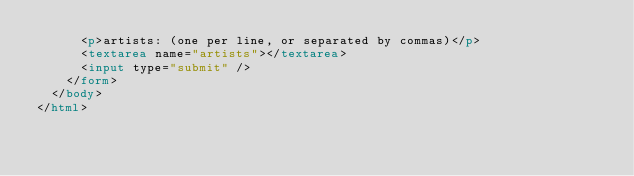<code> <loc_0><loc_0><loc_500><loc_500><_HTML_>      <p>artists: (one per line, or separated by commas)</p>
      <textarea name="artists"></textarea>
      <input type="submit" />
    </form>
  </body>
</html>
</code> 